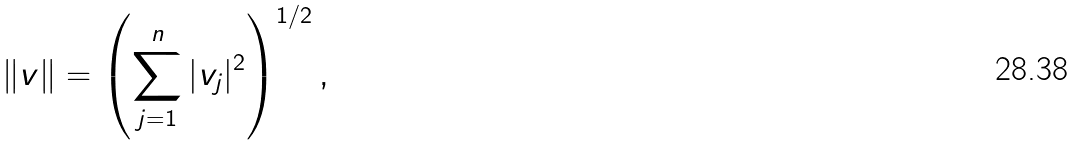<formula> <loc_0><loc_0><loc_500><loc_500>\| v \| = \left ( \sum _ { j = 1 } ^ { n } | v _ { j } | ^ { 2 } \right ) ^ { 1 / 2 } ,</formula> 